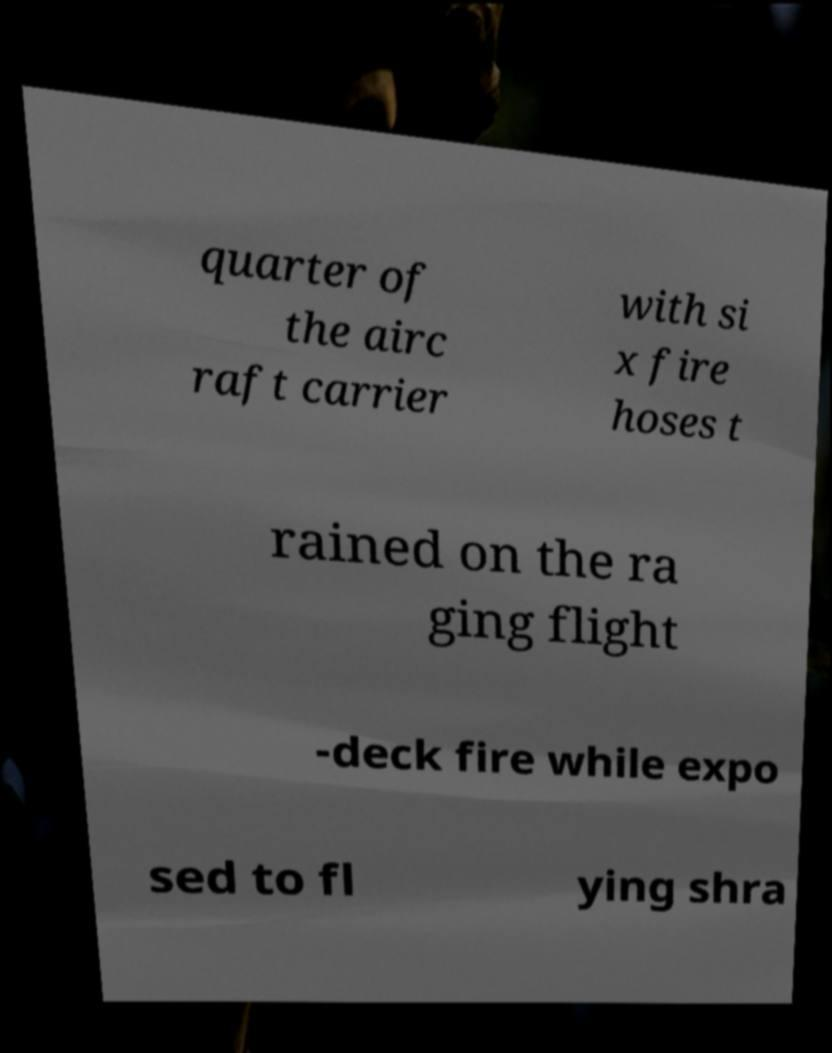There's text embedded in this image that I need extracted. Can you transcribe it verbatim? quarter of the airc raft carrier with si x fire hoses t rained on the ra ging flight -deck fire while expo sed to fl ying shra 